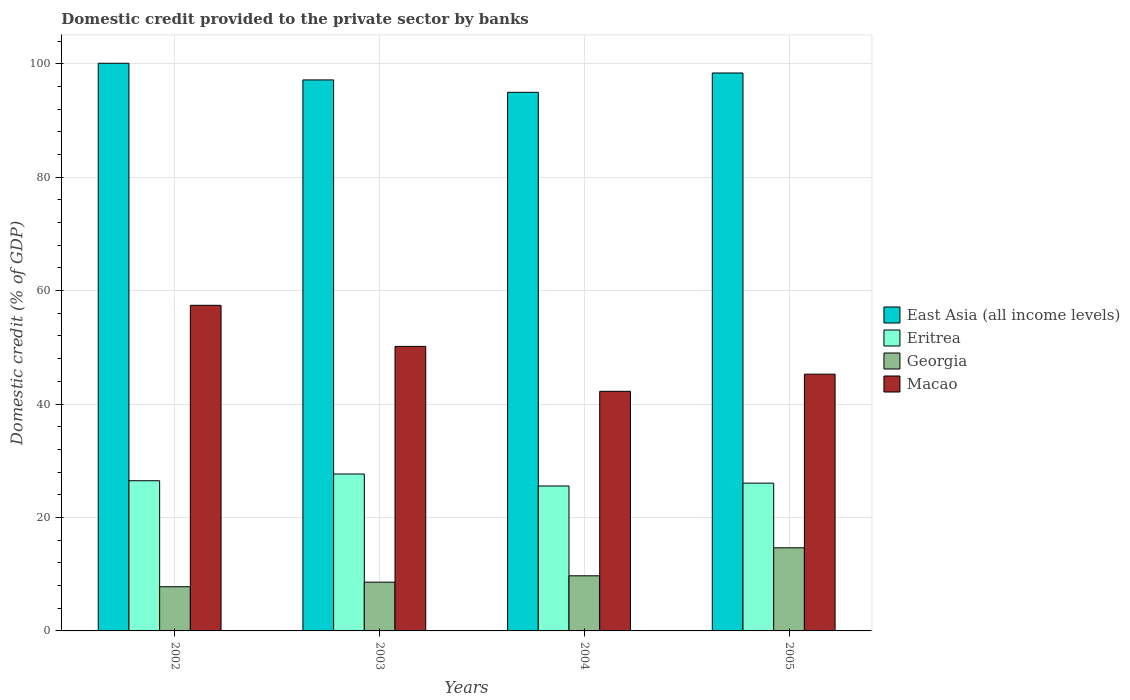How many groups of bars are there?
Provide a short and direct response. 4. Are the number of bars on each tick of the X-axis equal?
Ensure brevity in your answer.  Yes. How many bars are there on the 2nd tick from the left?
Make the answer very short. 4. How many bars are there on the 1st tick from the right?
Keep it short and to the point. 4. In how many cases, is the number of bars for a given year not equal to the number of legend labels?
Make the answer very short. 0. What is the domestic credit provided to the private sector by banks in Eritrea in 2004?
Make the answer very short. 25.55. Across all years, what is the maximum domestic credit provided to the private sector by banks in Georgia?
Ensure brevity in your answer.  14.66. Across all years, what is the minimum domestic credit provided to the private sector by banks in Macao?
Your response must be concise. 42.25. What is the total domestic credit provided to the private sector by banks in Eritrea in the graph?
Ensure brevity in your answer.  105.75. What is the difference between the domestic credit provided to the private sector by banks in East Asia (all income levels) in 2003 and that in 2005?
Provide a short and direct response. -1.22. What is the difference between the domestic credit provided to the private sector by banks in Eritrea in 2005 and the domestic credit provided to the private sector by banks in Georgia in 2004?
Make the answer very short. 16.34. What is the average domestic credit provided to the private sector by banks in East Asia (all income levels) per year?
Make the answer very short. 97.64. In the year 2003, what is the difference between the domestic credit provided to the private sector by banks in East Asia (all income levels) and domestic credit provided to the private sector by banks in Eritrea?
Offer a very short reply. 69.49. What is the ratio of the domestic credit provided to the private sector by banks in East Asia (all income levels) in 2003 to that in 2005?
Your response must be concise. 0.99. Is the domestic credit provided to the private sector by banks in East Asia (all income levels) in 2002 less than that in 2005?
Your answer should be compact. No. Is the difference between the domestic credit provided to the private sector by banks in East Asia (all income levels) in 2002 and 2005 greater than the difference between the domestic credit provided to the private sector by banks in Eritrea in 2002 and 2005?
Give a very brief answer. Yes. What is the difference between the highest and the second highest domestic credit provided to the private sector by banks in Eritrea?
Make the answer very short. 1.18. What is the difference between the highest and the lowest domestic credit provided to the private sector by banks in East Asia (all income levels)?
Give a very brief answer. 5.12. In how many years, is the domestic credit provided to the private sector by banks in Macao greater than the average domestic credit provided to the private sector by banks in Macao taken over all years?
Your answer should be very brief. 2. Is it the case that in every year, the sum of the domestic credit provided to the private sector by banks in East Asia (all income levels) and domestic credit provided to the private sector by banks in Eritrea is greater than the sum of domestic credit provided to the private sector by banks in Macao and domestic credit provided to the private sector by banks in Georgia?
Your answer should be compact. Yes. What does the 1st bar from the left in 2005 represents?
Your response must be concise. East Asia (all income levels). What does the 3rd bar from the right in 2003 represents?
Make the answer very short. Eritrea. Is it the case that in every year, the sum of the domestic credit provided to the private sector by banks in East Asia (all income levels) and domestic credit provided to the private sector by banks in Georgia is greater than the domestic credit provided to the private sector by banks in Macao?
Provide a short and direct response. Yes. Are all the bars in the graph horizontal?
Ensure brevity in your answer.  No. How many years are there in the graph?
Keep it short and to the point. 4. What is the difference between two consecutive major ticks on the Y-axis?
Offer a terse response. 20. Does the graph contain grids?
Offer a terse response. Yes. Where does the legend appear in the graph?
Your response must be concise. Center right. How many legend labels are there?
Ensure brevity in your answer.  4. How are the legend labels stacked?
Your response must be concise. Vertical. What is the title of the graph?
Make the answer very short. Domestic credit provided to the private sector by banks. What is the label or title of the X-axis?
Give a very brief answer. Years. What is the label or title of the Y-axis?
Make the answer very short. Domestic credit (% of GDP). What is the Domestic credit (% of GDP) in East Asia (all income levels) in 2002?
Offer a terse response. 100.09. What is the Domestic credit (% of GDP) in Eritrea in 2002?
Provide a short and direct response. 26.48. What is the Domestic credit (% of GDP) in Georgia in 2002?
Make the answer very short. 7.79. What is the Domestic credit (% of GDP) of Macao in 2002?
Provide a succinct answer. 57.41. What is the Domestic credit (% of GDP) of East Asia (all income levels) in 2003?
Ensure brevity in your answer.  97.15. What is the Domestic credit (% of GDP) of Eritrea in 2003?
Offer a terse response. 27.66. What is the Domestic credit (% of GDP) in Georgia in 2003?
Make the answer very short. 8.6. What is the Domestic credit (% of GDP) of Macao in 2003?
Offer a very short reply. 50.17. What is the Domestic credit (% of GDP) of East Asia (all income levels) in 2004?
Offer a terse response. 94.96. What is the Domestic credit (% of GDP) in Eritrea in 2004?
Keep it short and to the point. 25.55. What is the Domestic credit (% of GDP) of Georgia in 2004?
Provide a short and direct response. 9.72. What is the Domestic credit (% of GDP) in Macao in 2004?
Your response must be concise. 42.25. What is the Domestic credit (% of GDP) in East Asia (all income levels) in 2005?
Provide a short and direct response. 98.37. What is the Domestic credit (% of GDP) of Eritrea in 2005?
Provide a succinct answer. 26.06. What is the Domestic credit (% of GDP) of Georgia in 2005?
Ensure brevity in your answer.  14.66. What is the Domestic credit (% of GDP) of Macao in 2005?
Provide a short and direct response. 45.27. Across all years, what is the maximum Domestic credit (% of GDP) in East Asia (all income levels)?
Your answer should be very brief. 100.09. Across all years, what is the maximum Domestic credit (% of GDP) of Eritrea?
Give a very brief answer. 27.66. Across all years, what is the maximum Domestic credit (% of GDP) of Georgia?
Provide a succinct answer. 14.66. Across all years, what is the maximum Domestic credit (% of GDP) in Macao?
Make the answer very short. 57.41. Across all years, what is the minimum Domestic credit (% of GDP) of East Asia (all income levels)?
Offer a terse response. 94.96. Across all years, what is the minimum Domestic credit (% of GDP) of Eritrea?
Offer a very short reply. 25.55. Across all years, what is the minimum Domestic credit (% of GDP) of Georgia?
Offer a terse response. 7.79. Across all years, what is the minimum Domestic credit (% of GDP) in Macao?
Give a very brief answer. 42.25. What is the total Domestic credit (% of GDP) of East Asia (all income levels) in the graph?
Provide a succinct answer. 390.58. What is the total Domestic credit (% of GDP) of Eritrea in the graph?
Your answer should be compact. 105.75. What is the total Domestic credit (% of GDP) of Georgia in the graph?
Your answer should be compact. 40.76. What is the total Domestic credit (% of GDP) in Macao in the graph?
Keep it short and to the point. 195.1. What is the difference between the Domestic credit (% of GDP) in East Asia (all income levels) in 2002 and that in 2003?
Make the answer very short. 2.94. What is the difference between the Domestic credit (% of GDP) of Eritrea in 2002 and that in 2003?
Your answer should be compact. -1.18. What is the difference between the Domestic credit (% of GDP) of Georgia in 2002 and that in 2003?
Offer a terse response. -0.81. What is the difference between the Domestic credit (% of GDP) of Macao in 2002 and that in 2003?
Give a very brief answer. 7.24. What is the difference between the Domestic credit (% of GDP) of East Asia (all income levels) in 2002 and that in 2004?
Give a very brief answer. 5.12. What is the difference between the Domestic credit (% of GDP) of Eritrea in 2002 and that in 2004?
Offer a very short reply. 0.93. What is the difference between the Domestic credit (% of GDP) of Georgia in 2002 and that in 2004?
Your answer should be very brief. -1.93. What is the difference between the Domestic credit (% of GDP) in Macao in 2002 and that in 2004?
Provide a short and direct response. 15.16. What is the difference between the Domestic credit (% of GDP) in East Asia (all income levels) in 2002 and that in 2005?
Your answer should be very brief. 1.72. What is the difference between the Domestic credit (% of GDP) of Eritrea in 2002 and that in 2005?
Your answer should be compact. 0.42. What is the difference between the Domestic credit (% of GDP) in Georgia in 2002 and that in 2005?
Your answer should be compact. -6.87. What is the difference between the Domestic credit (% of GDP) in Macao in 2002 and that in 2005?
Ensure brevity in your answer.  12.14. What is the difference between the Domestic credit (% of GDP) of East Asia (all income levels) in 2003 and that in 2004?
Your answer should be compact. 2.19. What is the difference between the Domestic credit (% of GDP) of Eritrea in 2003 and that in 2004?
Keep it short and to the point. 2.11. What is the difference between the Domestic credit (% of GDP) of Georgia in 2003 and that in 2004?
Your response must be concise. -1.12. What is the difference between the Domestic credit (% of GDP) in Macao in 2003 and that in 2004?
Your response must be concise. 7.92. What is the difference between the Domestic credit (% of GDP) of East Asia (all income levels) in 2003 and that in 2005?
Offer a very short reply. -1.22. What is the difference between the Domestic credit (% of GDP) in Eritrea in 2003 and that in 2005?
Keep it short and to the point. 1.61. What is the difference between the Domestic credit (% of GDP) of Georgia in 2003 and that in 2005?
Your response must be concise. -6.06. What is the difference between the Domestic credit (% of GDP) in Macao in 2003 and that in 2005?
Your answer should be very brief. 4.9. What is the difference between the Domestic credit (% of GDP) of East Asia (all income levels) in 2004 and that in 2005?
Provide a short and direct response. -3.41. What is the difference between the Domestic credit (% of GDP) in Eritrea in 2004 and that in 2005?
Provide a succinct answer. -0.51. What is the difference between the Domestic credit (% of GDP) in Georgia in 2004 and that in 2005?
Offer a terse response. -4.94. What is the difference between the Domestic credit (% of GDP) of Macao in 2004 and that in 2005?
Ensure brevity in your answer.  -3.02. What is the difference between the Domestic credit (% of GDP) in East Asia (all income levels) in 2002 and the Domestic credit (% of GDP) in Eritrea in 2003?
Your answer should be very brief. 72.42. What is the difference between the Domestic credit (% of GDP) in East Asia (all income levels) in 2002 and the Domestic credit (% of GDP) in Georgia in 2003?
Your response must be concise. 91.49. What is the difference between the Domestic credit (% of GDP) of East Asia (all income levels) in 2002 and the Domestic credit (% of GDP) of Macao in 2003?
Your answer should be compact. 49.92. What is the difference between the Domestic credit (% of GDP) of Eritrea in 2002 and the Domestic credit (% of GDP) of Georgia in 2003?
Keep it short and to the point. 17.88. What is the difference between the Domestic credit (% of GDP) of Eritrea in 2002 and the Domestic credit (% of GDP) of Macao in 2003?
Offer a terse response. -23.69. What is the difference between the Domestic credit (% of GDP) in Georgia in 2002 and the Domestic credit (% of GDP) in Macao in 2003?
Provide a succinct answer. -42.38. What is the difference between the Domestic credit (% of GDP) of East Asia (all income levels) in 2002 and the Domestic credit (% of GDP) of Eritrea in 2004?
Your answer should be very brief. 74.54. What is the difference between the Domestic credit (% of GDP) of East Asia (all income levels) in 2002 and the Domestic credit (% of GDP) of Georgia in 2004?
Keep it short and to the point. 90.37. What is the difference between the Domestic credit (% of GDP) of East Asia (all income levels) in 2002 and the Domestic credit (% of GDP) of Macao in 2004?
Your response must be concise. 57.84. What is the difference between the Domestic credit (% of GDP) in Eritrea in 2002 and the Domestic credit (% of GDP) in Georgia in 2004?
Provide a short and direct response. 16.76. What is the difference between the Domestic credit (% of GDP) in Eritrea in 2002 and the Domestic credit (% of GDP) in Macao in 2004?
Your answer should be very brief. -15.77. What is the difference between the Domestic credit (% of GDP) in Georgia in 2002 and the Domestic credit (% of GDP) in Macao in 2004?
Offer a terse response. -34.46. What is the difference between the Domestic credit (% of GDP) of East Asia (all income levels) in 2002 and the Domestic credit (% of GDP) of Eritrea in 2005?
Offer a very short reply. 74.03. What is the difference between the Domestic credit (% of GDP) of East Asia (all income levels) in 2002 and the Domestic credit (% of GDP) of Georgia in 2005?
Your answer should be compact. 85.43. What is the difference between the Domestic credit (% of GDP) in East Asia (all income levels) in 2002 and the Domestic credit (% of GDP) in Macao in 2005?
Provide a short and direct response. 54.82. What is the difference between the Domestic credit (% of GDP) in Eritrea in 2002 and the Domestic credit (% of GDP) in Georgia in 2005?
Your response must be concise. 11.82. What is the difference between the Domestic credit (% of GDP) in Eritrea in 2002 and the Domestic credit (% of GDP) in Macao in 2005?
Provide a succinct answer. -18.79. What is the difference between the Domestic credit (% of GDP) of Georgia in 2002 and the Domestic credit (% of GDP) of Macao in 2005?
Offer a terse response. -37.48. What is the difference between the Domestic credit (% of GDP) of East Asia (all income levels) in 2003 and the Domestic credit (% of GDP) of Eritrea in 2004?
Make the answer very short. 71.6. What is the difference between the Domestic credit (% of GDP) in East Asia (all income levels) in 2003 and the Domestic credit (% of GDP) in Georgia in 2004?
Keep it short and to the point. 87.44. What is the difference between the Domestic credit (% of GDP) in East Asia (all income levels) in 2003 and the Domestic credit (% of GDP) in Macao in 2004?
Your answer should be very brief. 54.9. What is the difference between the Domestic credit (% of GDP) in Eritrea in 2003 and the Domestic credit (% of GDP) in Georgia in 2004?
Offer a terse response. 17.95. What is the difference between the Domestic credit (% of GDP) in Eritrea in 2003 and the Domestic credit (% of GDP) in Macao in 2004?
Your response must be concise. -14.59. What is the difference between the Domestic credit (% of GDP) of Georgia in 2003 and the Domestic credit (% of GDP) of Macao in 2004?
Your answer should be very brief. -33.65. What is the difference between the Domestic credit (% of GDP) in East Asia (all income levels) in 2003 and the Domestic credit (% of GDP) in Eritrea in 2005?
Provide a succinct answer. 71.09. What is the difference between the Domestic credit (% of GDP) of East Asia (all income levels) in 2003 and the Domestic credit (% of GDP) of Georgia in 2005?
Give a very brief answer. 82.5. What is the difference between the Domestic credit (% of GDP) in East Asia (all income levels) in 2003 and the Domestic credit (% of GDP) in Macao in 2005?
Provide a short and direct response. 51.88. What is the difference between the Domestic credit (% of GDP) in Eritrea in 2003 and the Domestic credit (% of GDP) in Georgia in 2005?
Make the answer very short. 13.01. What is the difference between the Domestic credit (% of GDP) of Eritrea in 2003 and the Domestic credit (% of GDP) of Macao in 2005?
Ensure brevity in your answer.  -17.61. What is the difference between the Domestic credit (% of GDP) in Georgia in 2003 and the Domestic credit (% of GDP) in Macao in 2005?
Provide a short and direct response. -36.67. What is the difference between the Domestic credit (% of GDP) in East Asia (all income levels) in 2004 and the Domestic credit (% of GDP) in Eritrea in 2005?
Ensure brevity in your answer.  68.91. What is the difference between the Domestic credit (% of GDP) in East Asia (all income levels) in 2004 and the Domestic credit (% of GDP) in Georgia in 2005?
Ensure brevity in your answer.  80.31. What is the difference between the Domestic credit (% of GDP) in East Asia (all income levels) in 2004 and the Domestic credit (% of GDP) in Macao in 2005?
Offer a terse response. 49.7. What is the difference between the Domestic credit (% of GDP) of Eritrea in 2004 and the Domestic credit (% of GDP) of Georgia in 2005?
Your answer should be very brief. 10.9. What is the difference between the Domestic credit (% of GDP) of Eritrea in 2004 and the Domestic credit (% of GDP) of Macao in 2005?
Provide a succinct answer. -19.72. What is the difference between the Domestic credit (% of GDP) of Georgia in 2004 and the Domestic credit (% of GDP) of Macao in 2005?
Provide a succinct answer. -35.55. What is the average Domestic credit (% of GDP) in East Asia (all income levels) per year?
Your answer should be compact. 97.64. What is the average Domestic credit (% of GDP) of Eritrea per year?
Keep it short and to the point. 26.44. What is the average Domestic credit (% of GDP) in Georgia per year?
Make the answer very short. 10.19. What is the average Domestic credit (% of GDP) in Macao per year?
Offer a terse response. 48.77. In the year 2002, what is the difference between the Domestic credit (% of GDP) of East Asia (all income levels) and Domestic credit (% of GDP) of Eritrea?
Offer a terse response. 73.61. In the year 2002, what is the difference between the Domestic credit (% of GDP) of East Asia (all income levels) and Domestic credit (% of GDP) of Georgia?
Offer a terse response. 92.3. In the year 2002, what is the difference between the Domestic credit (% of GDP) of East Asia (all income levels) and Domestic credit (% of GDP) of Macao?
Provide a short and direct response. 42.68. In the year 2002, what is the difference between the Domestic credit (% of GDP) in Eritrea and Domestic credit (% of GDP) in Georgia?
Offer a very short reply. 18.69. In the year 2002, what is the difference between the Domestic credit (% of GDP) of Eritrea and Domestic credit (% of GDP) of Macao?
Provide a short and direct response. -30.93. In the year 2002, what is the difference between the Domestic credit (% of GDP) of Georgia and Domestic credit (% of GDP) of Macao?
Offer a terse response. -49.62. In the year 2003, what is the difference between the Domestic credit (% of GDP) of East Asia (all income levels) and Domestic credit (% of GDP) of Eritrea?
Ensure brevity in your answer.  69.49. In the year 2003, what is the difference between the Domestic credit (% of GDP) in East Asia (all income levels) and Domestic credit (% of GDP) in Georgia?
Offer a very short reply. 88.56. In the year 2003, what is the difference between the Domestic credit (% of GDP) of East Asia (all income levels) and Domestic credit (% of GDP) of Macao?
Your answer should be very brief. 46.99. In the year 2003, what is the difference between the Domestic credit (% of GDP) in Eritrea and Domestic credit (% of GDP) in Georgia?
Provide a short and direct response. 19.07. In the year 2003, what is the difference between the Domestic credit (% of GDP) in Eritrea and Domestic credit (% of GDP) in Macao?
Ensure brevity in your answer.  -22.5. In the year 2003, what is the difference between the Domestic credit (% of GDP) of Georgia and Domestic credit (% of GDP) of Macao?
Keep it short and to the point. -41.57. In the year 2004, what is the difference between the Domestic credit (% of GDP) in East Asia (all income levels) and Domestic credit (% of GDP) in Eritrea?
Ensure brevity in your answer.  69.41. In the year 2004, what is the difference between the Domestic credit (% of GDP) of East Asia (all income levels) and Domestic credit (% of GDP) of Georgia?
Provide a succinct answer. 85.25. In the year 2004, what is the difference between the Domestic credit (% of GDP) of East Asia (all income levels) and Domestic credit (% of GDP) of Macao?
Keep it short and to the point. 52.72. In the year 2004, what is the difference between the Domestic credit (% of GDP) of Eritrea and Domestic credit (% of GDP) of Georgia?
Your answer should be very brief. 15.83. In the year 2004, what is the difference between the Domestic credit (% of GDP) of Eritrea and Domestic credit (% of GDP) of Macao?
Keep it short and to the point. -16.7. In the year 2004, what is the difference between the Domestic credit (% of GDP) of Georgia and Domestic credit (% of GDP) of Macao?
Your answer should be compact. -32.53. In the year 2005, what is the difference between the Domestic credit (% of GDP) in East Asia (all income levels) and Domestic credit (% of GDP) in Eritrea?
Make the answer very short. 72.32. In the year 2005, what is the difference between the Domestic credit (% of GDP) in East Asia (all income levels) and Domestic credit (% of GDP) in Georgia?
Ensure brevity in your answer.  83.72. In the year 2005, what is the difference between the Domestic credit (% of GDP) in East Asia (all income levels) and Domestic credit (% of GDP) in Macao?
Ensure brevity in your answer.  53.1. In the year 2005, what is the difference between the Domestic credit (% of GDP) in Eritrea and Domestic credit (% of GDP) in Georgia?
Keep it short and to the point. 11.4. In the year 2005, what is the difference between the Domestic credit (% of GDP) of Eritrea and Domestic credit (% of GDP) of Macao?
Your answer should be compact. -19.21. In the year 2005, what is the difference between the Domestic credit (% of GDP) in Georgia and Domestic credit (% of GDP) in Macao?
Provide a short and direct response. -30.61. What is the ratio of the Domestic credit (% of GDP) in East Asia (all income levels) in 2002 to that in 2003?
Offer a terse response. 1.03. What is the ratio of the Domestic credit (% of GDP) of Eritrea in 2002 to that in 2003?
Your response must be concise. 0.96. What is the ratio of the Domestic credit (% of GDP) in Georgia in 2002 to that in 2003?
Ensure brevity in your answer.  0.91. What is the ratio of the Domestic credit (% of GDP) of Macao in 2002 to that in 2003?
Make the answer very short. 1.14. What is the ratio of the Domestic credit (% of GDP) of East Asia (all income levels) in 2002 to that in 2004?
Give a very brief answer. 1.05. What is the ratio of the Domestic credit (% of GDP) in Eritrea in 2002 to that in 2004?
Give a very brief answer. 1.04. What is the ratio of the Domestic credit (% of GDP) of Georgia in 2002 to that in 2004?
Offer a very short reply. 0.8. What is the ratio of the Domestic credit (% of GDP) in Macao in 2002 to that in 2004?
Give a very brief answer. 1.36. What is the ratio of the Domestic credit (% of GDP) of East Asia (all income levels) in 2002 to that in 2005?
Your response must be concise. 1.02. What is the ratio of the Domestic credit (% of GDP) of Eritrea in 2002 to that in 2005?
Give a very brief answer. 1.02. What is the ratio of the Domestic credit (% of GDP) of Georgia in 2002 to that in 2005?
Offer a terse response. 0.53. What is the ratio of the Domestic credit (% of GDP) of Macao in 2002 to that in 2005?
Offer a terse response. 1.27. What is the ratio of the Domestic credit (% of GDP) of Eritrea in 2003 to that in 2004?
Your answer should be very brief. 1.08. What is the ratio of the Domestic credit (% of GDP) in Georgia in 2003 to that in 2004?
Ensure brevity in your answer.  0.88. What is the ratio of the Domestic credit (% of GDP) of Macao in 2003 to that in 2004?
Offer a terse response. 1.19. What is the ratio of the Domestic credit (% of GDP) in East Asia (all income levels) in 2003 to that in 2005?
Provide a short and direct response. 0.99. What is the ratio of the Domestic credit (% of GDP) of Eritrea in 2003 to that in 2005?
Your answer should be very brief. 1.06. What is the ratio of the Domestic credit (% of GDP) in Georgia in 2003 to that in 2005?
Your answer should be compact. 0.59. What is the ratio of the Domestic credit (% of GDP) in Macao in 2003 to that in 2005?
Make the answer very short. 1.11. What is the ratio of the Domestic credit (% of GDP) of East Asia (all income levels) in 2004 to that in 2005?
Your answer should be very brief. 0.97. What is the ratio of the Domestic credit (% of GDP) of Eritrea in 2004 to that in 2005?
Offer a very short reply. 0.98. What is the ratio of the Domestic credit (% of GDP) of Georgia in 2004 to that in 2005?
Offer a terse response. 0.66. What is the difference between the highest and the second highest Domestic credit (% of GDP) of East Asia (all income levels)?
Make the answer very short. 1.72. What is the difference between the highest and the second highest Domestic credit (% of GDP) of Eritrea?
Your answer should be very brief. 1.18. What is the difference between the highest and the second highest Domestic credit (% of GDP) of Georgia?
Provide a short and direct response. 4.94. What is the difference between the highest and the second highest Domestic credit (% of GDP) in Macao?
Ensure brevity in your answer.  7.24. What is the difference between the highest and the lowest Domestic credit (% of GDP) of East Asia (all income levels)?
Your response must be concise. 5.12. What is the difference between the highest and the lowest Domestic credit (% of GDP) in Eritrea?
Give a very brief answer. 2.11. What is the difference between the highest and the lowest Domestic credit (% of GDP) in Georgia?
Provide a short and direct response. 6.87. What is the difference between the highest and the lowest Domestic credit (% of GDP) of Macao?
Give a very brief answer. 15.16. 